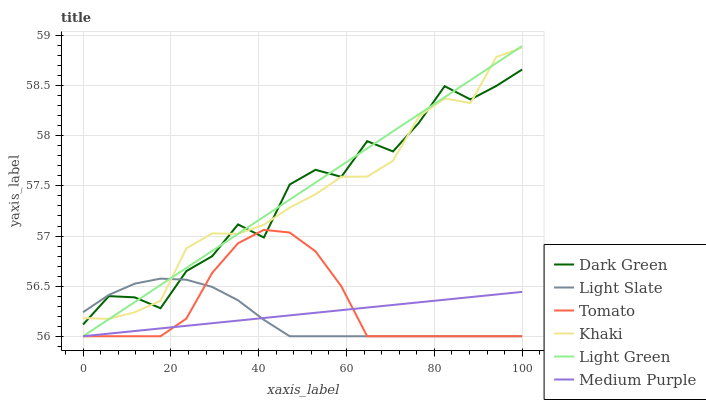Does Light Slate have the minimum area under the curve?
Answer yes or no. Yes. Does Light Green have the maximum area under the curve?
Answer yes or no. Yes. Does Khaki have the minimum area under the curve?
Answer yes or no. No. Does Khaki have the maximum area under the curve?
Answer yes or no. No. Is Light Green the smoothest?
Answer yes or no. Yes. Is Dark Green the roughest?
Answer yes or no. Yes. Is Khaki the smoothest?
Answer yes or no. No. Is Khaki the roughest?
Answer yes or no. No. Does Tomato have the lowest value?
Answer yes or no. Yes. Does Khaki have the lowest value?
Answer yes or no. No. Does Light Green have the highest value?
Answer yes or no. Yes. Does Khaki have the highest value?
Answer yes or no. No. Is Medium Purple less than Dark Green?
Answer yes or no. Yes. Is Khaki greater than Medium Purple?
Answer yes or no. Yes. Does Light Green intersect Light Slate?
Answer yes or no. Yes. Is Light Green less than Light Slate?
Answer yes or no. No. Is Light Green greater than Light Slate?
Answer yes or no. No. Does Medium Purple intersect Dark Green?
Answer yes or no. No. 